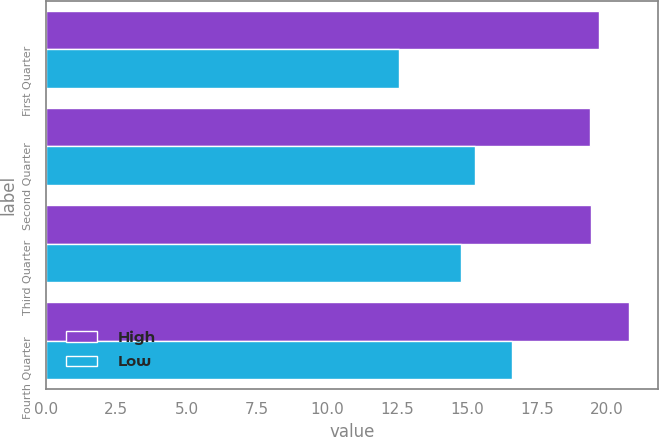<chart> <loc_0><loc_0><loc_500><loc_500><stacked_bar_chart><ecel><fcel>First Quarter<fcel>Second Quarter<fcel>Third Quarter<fcel>Fourth Quarter<nl><fcel>High<fcel>19.72<fcel>19.4<fcel>19.42<fcel>20.79<nl><fcel>Low<fcel>12.59<fcel>15.27<fcel>14.8<fcel>16.59<nl></chart> 